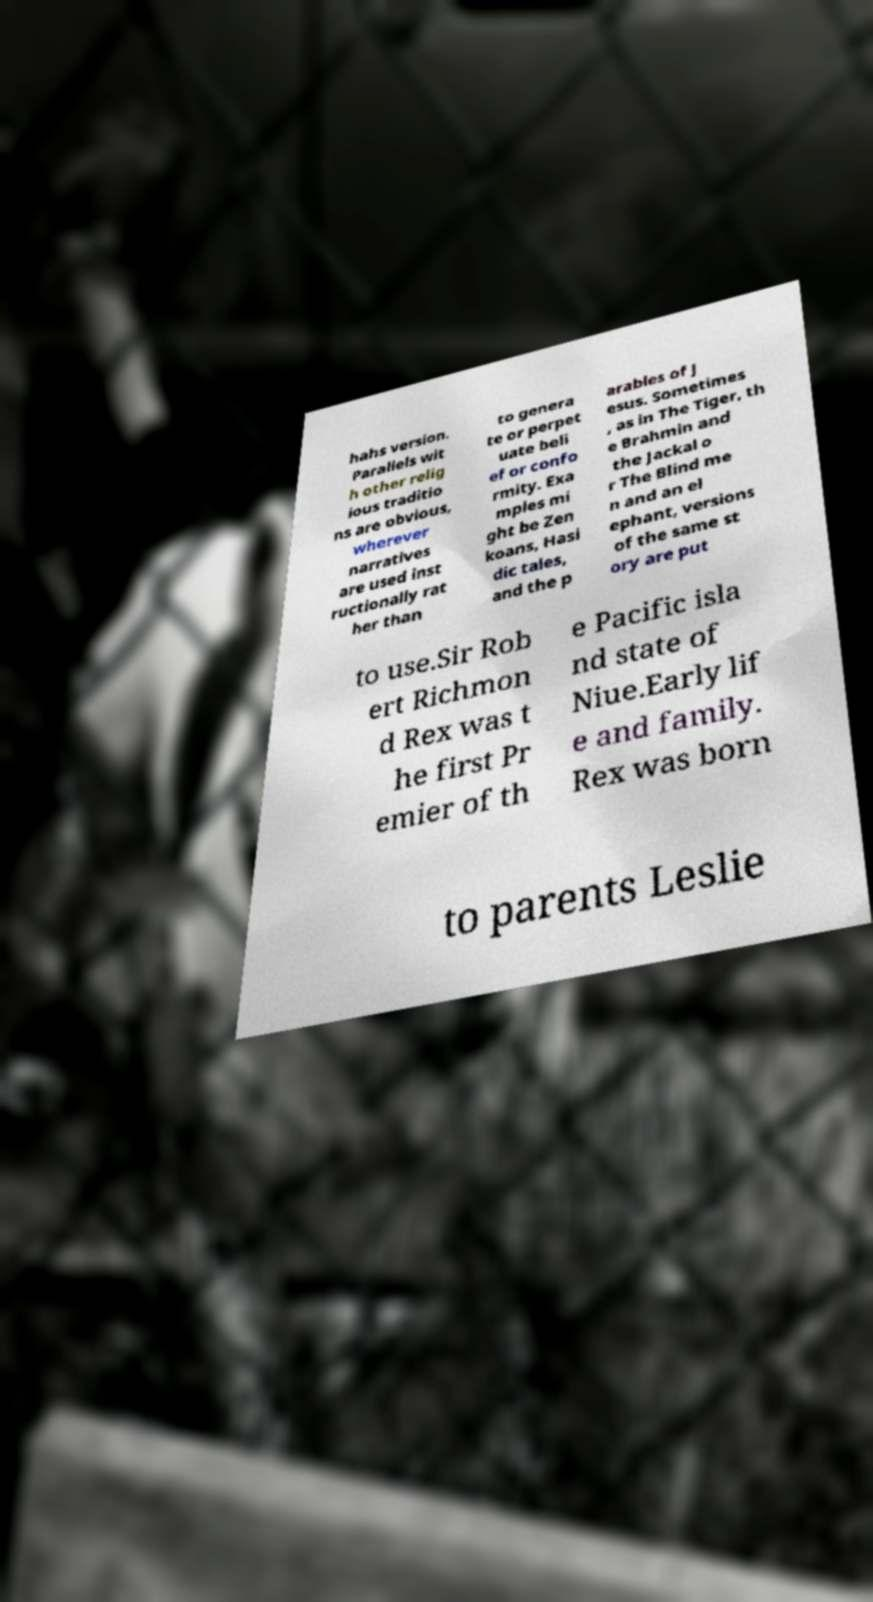Can you read and provide the text displayed in the image?This photo seems to have some interesting text. Can you extract and type it out for me? hahs version. Parallels wit h other relig ious traditio ns are obvious, wherever narratives are used inst ructionally rat her than to genera te or perpet uate beli ef or confo rmity. Exa mples mi ght be Zen koans, Hasi dic tales, and the p arables of J esus. Sometimes , as in The Tiger, th e Brahmin and the Jackal o r The Blind me n and an el ephant, versions of the same st ory are put to use.Sir Rob ert Richmon d Rex was t he first Pr emier of th e Pacific isla nd state of Niue.Early lif e and family. Rex was born to parents Leslie 